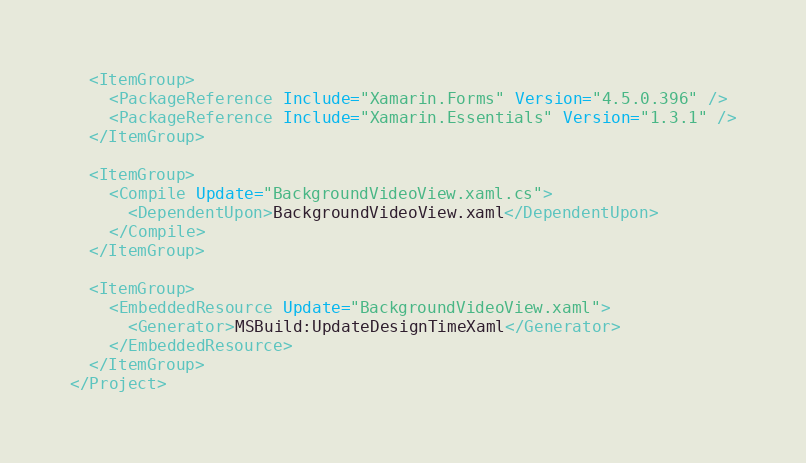Convert code to text. <code><loc_0><loc_0><loc_500><loc_500><_XML_>  <ItemGroup>
    <PackageReference Include="Xamarin.Forms" Version="4.5.0.396" />
    <PackageReference Include="Xamarin.Essentials" Version="1.3.1" />
  </ItemGroup>

  <ItemGroup>
    <Compile Update="BackgroundVideoView.xaml.cs">
      <DependentUpon>BackgroundVideoView.xaml</DependentUpon>
    </Compile>
  </ItemGroup>

  <ItemGroup>
    <EmbeddedResource Update="BackgroundVideoView.xaml">
      <Generator>MSBuild:UpdateDesignTimeXaml</Generator>
    </EmbeddedResource>
  </ItemGroup>
</Project>
</code> 